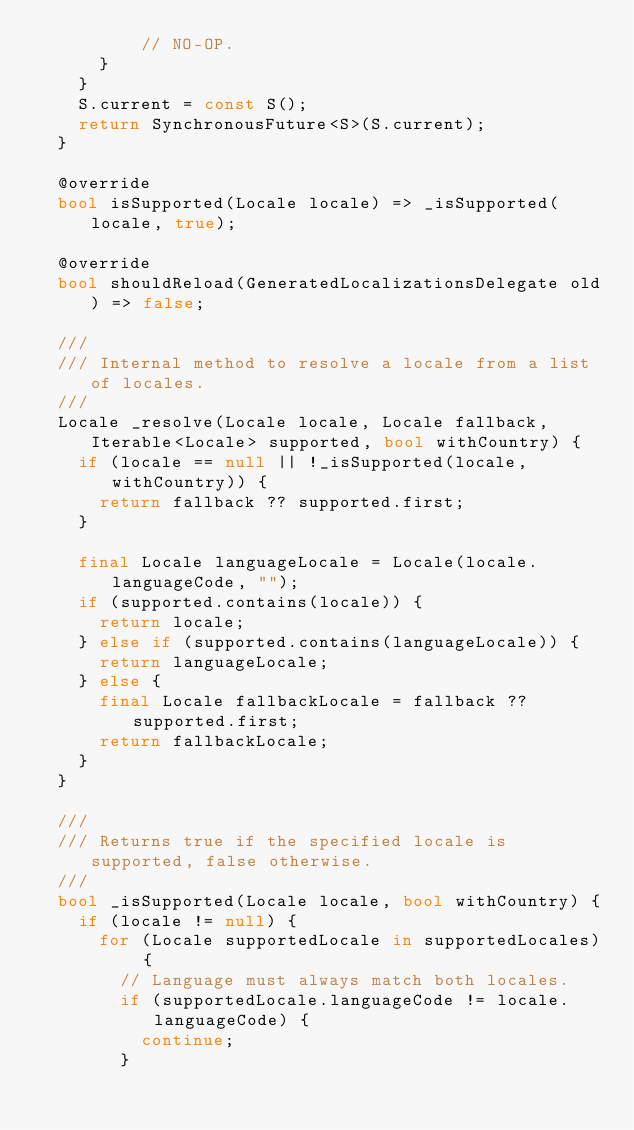<code> <loc_0><loc_0><loc_500><loc_500><_Dart_>          // NO-OP.
      }
    }
    S.current = const S();
    return SynchronousFuture<S>(S.current);
  }

  @override
  bool isSupported(Locale locale) => _isSupported(locale, true);

  @override
  bool shouldReload(GeneratedLocalizationsDelegate old) => false;

  ///
  /// Internal method to resolve a locale from a list of locales.
  ///
  Locale _resolve(Locale locale, Locale fallback, Iterable<Locale> supported, bool withCountry) {
    if (locale == null || !_isSupported(locale, withCountry)) {
      return fallback ?? supported.first;
    }

    final Locale languageLocale = Locale(locale.languageCode, "");
    if (supported.contains(locale)) {
      return locale;
    } else if (supported.contains(languageLocale)) {
      return languageLocale;
    } else {
      final Locale fallbackLocale = fallback ?? supported.first;
      return fallbackLocale;
    }
  }

  ///
  /// Returns true if the specified locale is supported, false otherwise.
  ///
  bool _isSupported(Locale locale, bool withCountry) {
    if (locale != null) {
      for (Locale supportedLocale in supportedLocales) {
        // Language must always match both locales.
        if (supportedLocale.languageCode != locale.languageCode) {
          continue;
        }
</code> 